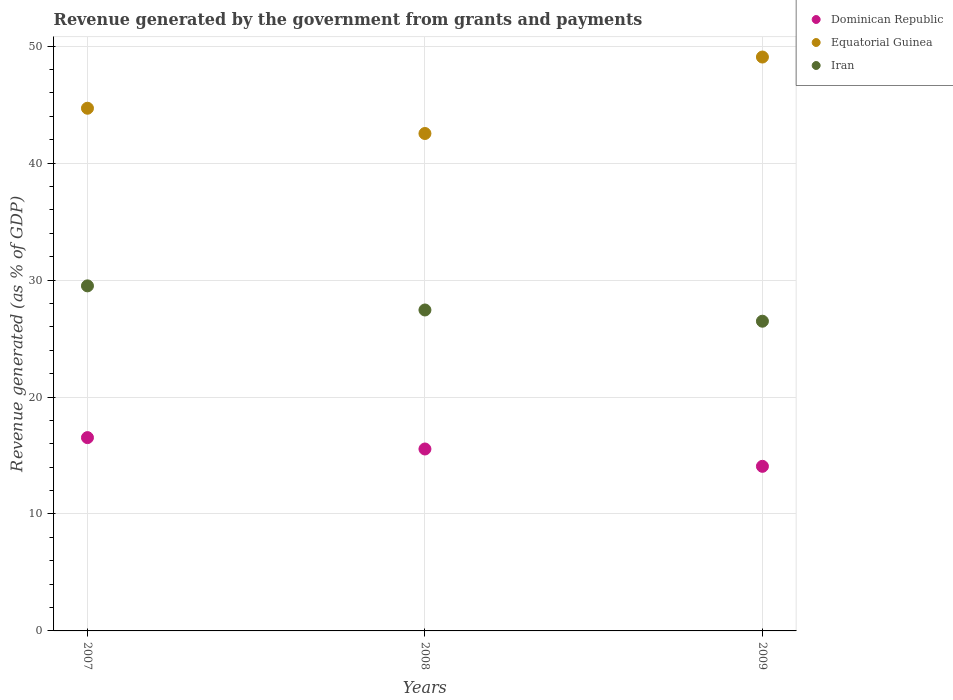How many different coloured dotlines are there?
Offer a terse response. 3. What is the revenue generated by the government in Iran in 2008?
Provide a succinct answer. 27.44. Across all years, what is the maximum revenue generated by the government in Dominican Republic?
Your response must be concise. 16.53. Across all years, what is the minimum revenue generated by the government in Dominican Republic?
Ensure brevity in your answer.  14.08. In which year was the revenue generated by the government in Iran maximum?
Offer a very short reply. 2007. In which year was the revenue generated by the government in Dominican Republic minimum?
Your response must be concise. 2009. What is the total revenue generated by the government in Iran in the graph?
Ensure brevity in your answer.  83.44. What is the difference between the revenue generated by the government in Equatorial Guinea in 2007 and that in 2008?
Provide a succinct answer. 2.16. What is the difference between the revenue generated by the government in Equatorial Guinea in 2008 and the revenue generated by the government in Iran in 2007?
Your answer should be very brief. 13.03. What is the average revenue generated by the government in Iran per year?
Make the answer very short. 27.81. In the year 2009, what is the difference between the revenue generated by the government in Dominican Republic and revenue generated by the government in Equatorial Guinea?
Ensure brevity in your answer.  -35. In how many years, is the revenue generated by the government in Equatorial Guinea greater than 14 %?
Your answer should be compact. 3. What is the ratio of the revenue generated by the government in Dominican Republic in 2007 to that in 2009?
Your answer should be compact. 1.17. What is the difference between the highest and the second highest revenue generated by the government in Equatorial Guinea?
Provide a short and direct response. 4.38. What is the difference between the highest and the lowest revenue generated by the government in Equatorial Guinea?
Ensure brevity in your answer.  6.54. Is it the case that in every year, the sum of the revenue generated by the government in Iran and revenue generated by the government in Equatorial Guinea  is greater than the revenue generated by the government in Dominican Republic?
Offer a terse response. Yes. Is the revenue generated by the government in Dominican Republic strictly greater than the revenue generated by the government in Equatorial Guinea over the years?
Keep it short and to the point. No. How many dotlines are there?
Provide a short and direct response. 3. How many years are there in the graph?
Offer a very short reply. 3. What is the difference between two consecutive major ticks on the Y-axis?
Your answer should be compact. 10. Are the values on the major ticks of Y-axis written in scientific E-notation?
Provide a short and direct response. No. Does the graph contain any zero values?
Your answer should be compact. No. Does the graph contain grids?
Keep it short and to the point. Yes. What is the title of the graph?
Your answer should be very brief. Revenue generated by the government from grants and payments. Does "Guyana" appear as one of the legend labels in the graph?
Your response must be concise. No. What is the label or title of the X-axis?
Keep it short and to the point. Years. What is the label or title of the Y-axis?
Give a very brief answer. Revenue generated (as % of GDP). What is the Revenue generated (as % of GDP) in Dominican Republic in 2007?
Give a very brief answer. 16.53. What is the Revenue generated (as % of GDP) of Equatorial Guinea in 2007?
Offer a very short reply. 44.7. What is the Revenue generated (as % of GDP) in Iran in 2007?
Offer a terse response. 29.51. What is the Revenue generated (as % of GDP) of Dominican Republic in 2008?
Ensure brevity in your answer.  15.56. What is the Revenue generated (as % of GDP) in Equatorial Guinea in 2008?
Give a very brief answer. 42.54. What is the Revenue generated (as % of GDP) in Iran in 2008?
Offer a terse response. 27.44. What is the Revenue generated (as % of GDP) in Dominican Republic in 2009?
Keep it short and to the point. 14.08. What is the Revenue generated (as % of GDP) of Equatorial Guinea in 2009?
Ensure brevity in your answer.  49.07. What is the Revenue generated (as % of GDP) in Iran in 2009?
Your response must be concise. 26.48. Across all years, what is the maximum Revenue generated (as % of GDP) in Dominican Republic?
Your response must be concise. 16.53. Across all years, what is the maximum Revenue generated (as % of GDP) in Equatorial Guinea?
Keep it short and to the point. 49.07. Across all years, what is the maximum Revenue generated (as % of GDP) in Iran?
Offer a very short reply. 29.51. Across all years, what is the minimum Revenue generated (as % of GDP) of Dominican Republic?
Give a very brief answer. 14.08. Across all years, what is the minimum Revenue generated (as % of GDP) in Equatorial Guinea?
Your answer should be very brief. 42.54. Across all years, what is the minimum Revenue generated (as % of GDP) in Iran?
Give a very brief answer. 26.48. What is the total Revenue generated (as % of GDP) of Dominican Republic in the graph?
Your answer should be compact. 46.16. What is the total Revenue generated (as % of GDP) of Equatorial Guinea in the graph?
Offer a very short reply. 136.31. What is the total Revenue generated (as % of GDP) of Iran in the graph?
Your response must be concise. 83.44. What is the difference between the Revenue generated (as % of GDP) in Dominican Republic in 2007 and that in 2008?
Your answer should be very brief. 0.97. What is the difference between the Revenue generated (as % of GDP) in Equatorial Guinea in 2007 and that in 2008?
Keep it short and to the point. 2.16. What is the difference between the Revenue generated (as % of GDP) in Iran in 2007 and that in 2008?
Ensure brevity in your answer.  2.06. What is the difference between the Revenue generated (as % of GDP) of Dominican Republic in 2007 and that in 2009?
Ensure brevity in your answer.  2.46. What is the difference between the Revenue generated (as % of GDP) in Equatorial Guinea in 2007 and that in 2009?
Make the answer very short. -4.38. What is the difference between the Revenue generated (as % of GDP) in Iran in 2007 and that in 2009?
Provide a succinct answer. 3.02. What is the difference between the Revenue generated (as % of GDP) in Dominican Republic in 2008 and that in 2009?
Your answer should be very brief. 1.48. What is the difference between the Revenue generated (as % of GDP) in Equatorial Guinea in 2008 and that in 2009?
Provide a short and direct response. -6.54. What is the difference between the Revenue generated (as % of GDP) in Iran in 2008 and that in 2009?
Ensure brevity in your answer.  0.96. What is the difference between the Revenue generated (as % of GDP) of Dominican Republic in 2007 and the Revenue generated (as % of GDP) of Equatorial Guinea in 2008?
Offer a very short reply. -26.01. What is the difference between the Revenue generated (as % of GDP) of Dominican Republic in 2007 and the Revenue generated (as % of GDP) of Iran in 2008?
Offer a terse response. -10.91. What is the difference between the Revenue generated (as % of GDP) in Equatorial Guinea in 2007 and the Revenue generated (as % of GDP) in Iran in 2008?
Your answer should be compact. 17.25. What is the difference between the Revenue generated (as % of GDP) in Dominican Republic in 2007 and the Revenue generated (as % of GDP) in Equatorial Guinea in 2009?
Make the answer very short. -32.54. What is the difference between the Revenue generated (as % of GDP) in Dominican Republic in 2007 and the Revenue generated (as % of GDP) in Iran in 2009?
Ensure brevity in your answer.  -9.95. What is the difference between the Revenue generated (as % of GDP) of Equatorial Guinea in 2007 and the Revenue generated (as % of GDP) of Iran in 2009?
Give a very brief answer. 18.21. What is the difference between the Revenue generated (as % of GDP) in Dominican Republic in 2008 and the Revenue generated (as % of GDP) in Equatorial Guinea in 2009?
Make the answer very short. -33.52. What is the difference between the Revenue generated (as % of GDP) in Dominican Republic in 2008 and the Revenue generated (as % of GDP) in Iran in 2009?
Provide a short and direct response. -10.93. What is the difference between the Revenue generated (as % of GDP) of Equatorial Guinea in 2008 and the Revenue generated (as % of GDP) of Iran in 2009?
Give a very brief answer. 16.05. What is the average Revenue generated (as % of GDP) in Dominican Republic per year?
Give a very brief answer. 15.39. What is the average Revenue generated (as % of GDP) of Equatorial Guinea per year?
Make the answer very short. 45.44. What is the average Revenue generated (as % of GDP) of Iran per year?
Your answer should be very brief. 27.81. In the year 2007, what is the difference between the Revenue generated (as % of GDP) in Dominican Republic and Revenue generated (as % of GDP) in Equatorial Guinea?
Offer a terse response. -28.17. In the year 2007, what is the difference between the Revenue generated (as % of GDP) of Dominican Republic and Revenue generated (as % of GDP) of Iran?
Your response must be concise. -12.98. In the year 2007, what is the difference between the Revenue generated (as % of GDP) of Equatorial Guinea and Revenue generated (as % of GDP) of Iran?
Make the answer very short. 15.19. In the year 2008, what is the difference between the Revenue generated (as % of GDP) of Dominican Republic and Revenue generated (as % of GDP) of Equatorial Guinea?
Provide a succinct answer. -26.98. In the year 2008, what is the difference between the Revenue generated (as % of GDP) of Dominican Republic and Revenue generated (as % of GDP) of Iran?
Offer a very short reply. -11.89. In the year 2008, what is the difference between the Revenue generated (as % of GDP) of Equatorial Guinea and Revenue generated (as % of GDP) of Iran?
Offer a very short reply. 15.09. In the year 2009, what is the difference between the Revenue generated (as % of GDP) of Dominican Republic and Revenue generated (as % of GDP) of Equatorial Guinea?
Provide a succinct answer. -35. In the year 2009, what is the difference between the Revenue generated (as % of GDP) of Dominican Republic and Revenue generated (as % of GDP) of Iran?
Give a very brief answer. -12.41. In the year 2009, what is the difference between the Revenue generated (as % of GDP) of Equatorial Guinea and Revenue generated (as % of GDP) of Iran?
Provide a short and direct response. 22.59. What is the ratio of the Revenue generated (as % of GDP) of Dominican Republic in 2007 to that in 2008?
Offer a very short reply. 1.06. What is the ratio of the Revenue generated (as % of GDP) in Equatorial Guinea in 2007 to that in 2008?
Make the answer very short. 1.05. What is the ratio of the Revenue generated (as % of GDP) in Iran in 2007 to that in 2008?
Give a very brief answer. 1.08. What is the ratio of the Revenue generated (as % of GDP) of Dominican Republic in 2007 to that in 2009?
Ensure brevity in your answer.  1.17. What is the ratio of the Revenue generated (as % of GDP) in Equatorial Guinea in 2007 to that in 2009?
Ensure brevity in your answer.  0.91. What is the ratio of the Revenue generated (as % of GDP) of Iran in 2007 to that in 2009?
Keep it short and to the point. 1.11. What is the ratio of the Revenue generated (as % of GDP) in Dominican Republic in 2008 to that in 2009?
Give a very brief answer. 1.11. What is the ratio of the Revenue generated (as % of GDP) in Equatorial Guinea in 2008 to that in 2009?
Provide a succinct answer. 0.87. What is the ratio of the Revenue generated (as % of GDP) of Iran in 2008 to that in 2009?
Your answer should be compact. 1.04. What is the difference between the highest and the second highest Revenue generated (as % of GDP) in Dominican Republic?
Keep it short and to the point. 0.97. What is the difference between the highest and the second highest Revenue generated (as % of GDP) in Equatorial Guinea?
Ensure brevity in your answer.  4.38. What is the difference between the highest and the second highest Revenue generated (as % of GDP) of Iran?
Your response must be concise. 2.06. What is the difference between the highest and the lowest Revenue generated (as % of GDP) of Dominican Republic?
Ensure brevity in your answer.  2.46. What is the difference between the highest and the lowest Revenue generated (as % of GDP) of Equatorial Guinea?
Offer a very short reply. 6.54. What is the difference between the highest and the lowest Revenue generated (as % of GDP) in Iran?
Provide a short and direct response. 3.02. 